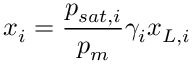<formula> <loc_0><loc_0><loc_500><loc_500>x _ { i } = \frac { p _ { s a t , i } } { p _ { m } } \gamma _ { i } x _ { L , i }</formula> 